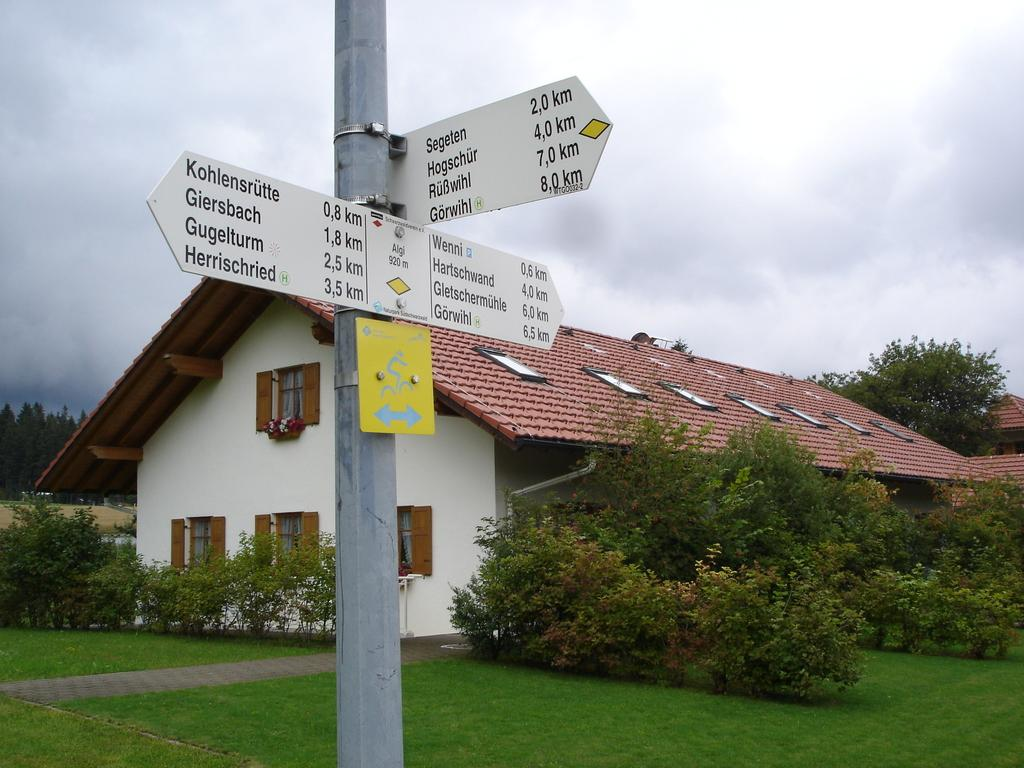<image>
Present a compact description of the photo's key features. A sign post  which indicates it is 2.0 km to Segeten 